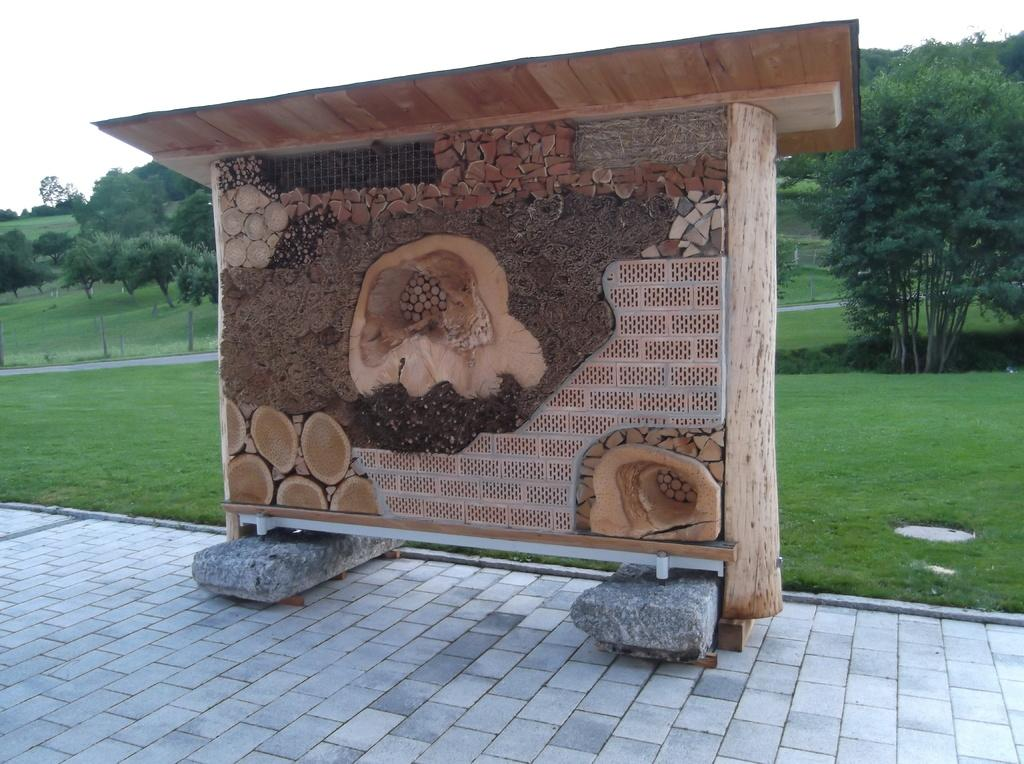What is located in the center of the image? There is a wall in the center of the image. What can be seen in the background of the image? There are trees in the background of the image. What type of vegetation is on the ground in the image? There is grass on the ground in the image. What is the condition of the sky in the image? The sky is cloudy in the image. What type of cannon is being used for breakfast in the image? There is no cannon or breakfast present in the image. Is there a water source visible in the image? No, there is no water source visible in the image. 